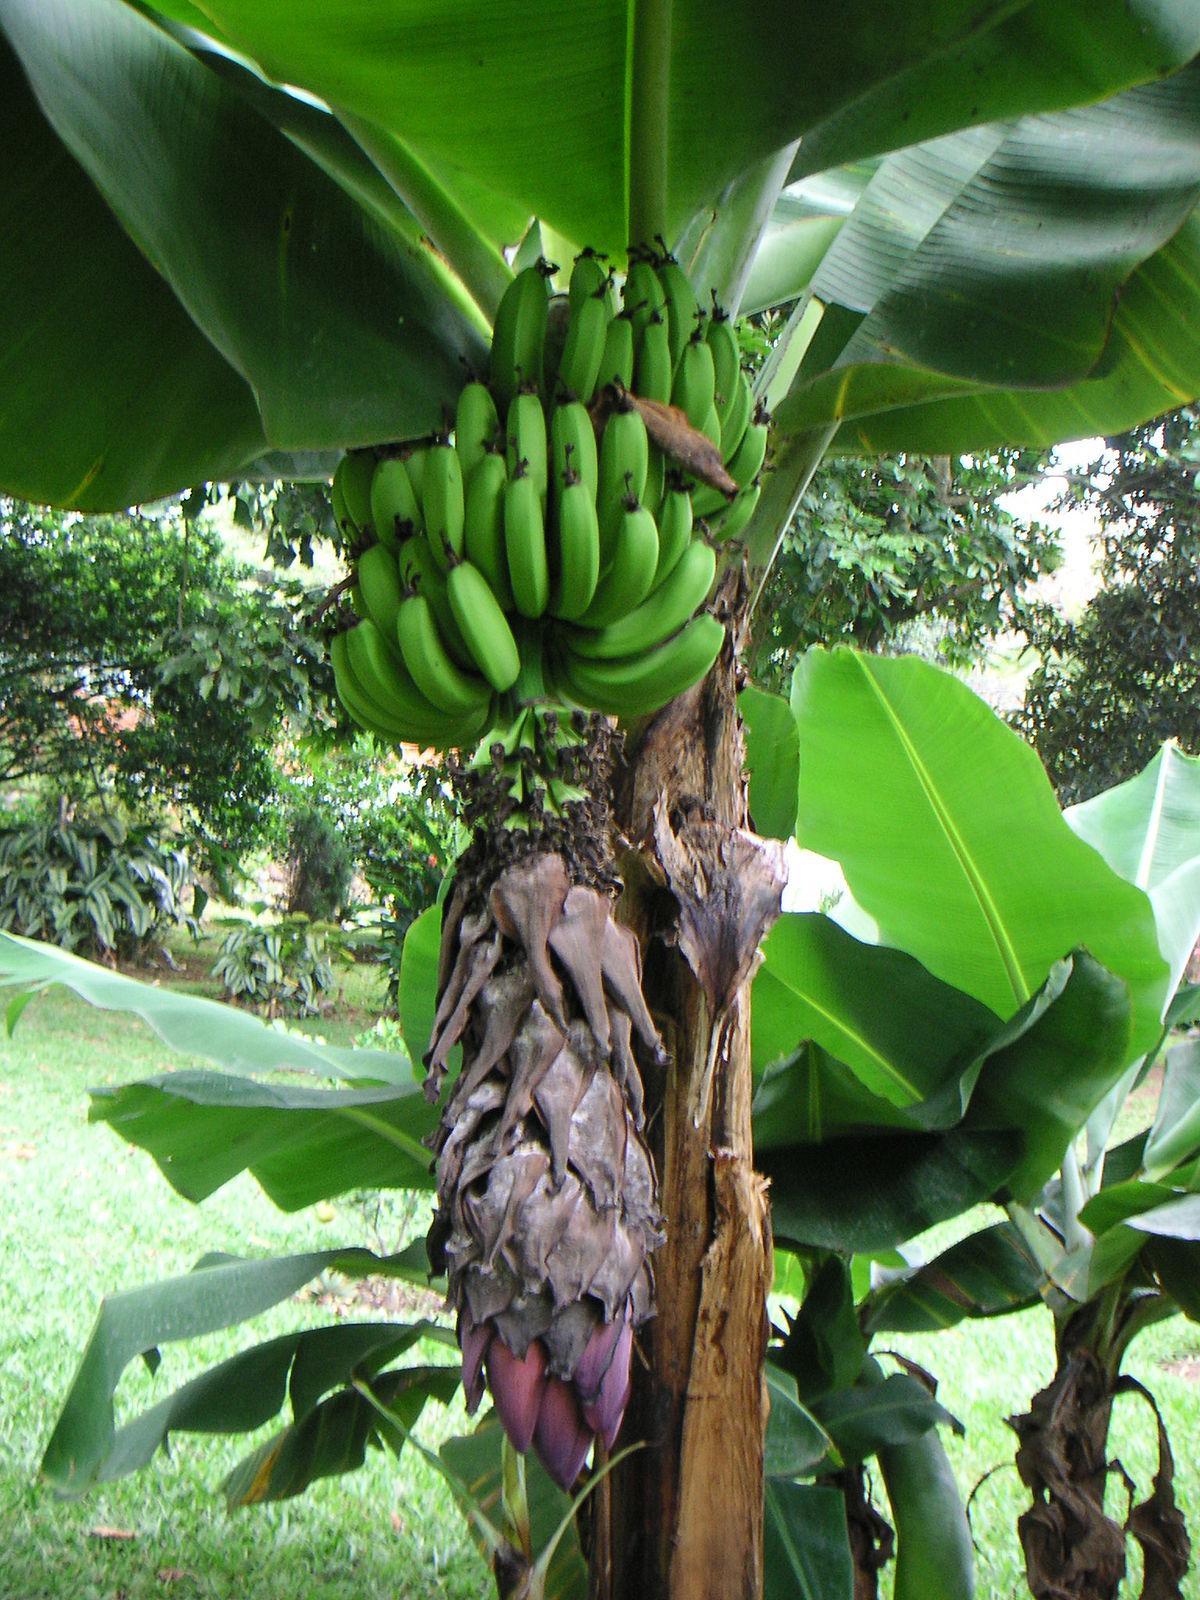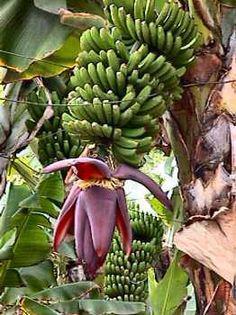The first image is the image on the left, the second image is the image on the right. Evaluate the accuracy of this statement regarding the images: "The righthand image shows a big purple flower with red underside of a petal visible below a bunch of green bananas, but the left image does not show any red undersides of petals.". Is it true? Answer yes or no. Yes. The first image is the image on the left, the second image is the image on the right. Given the left and right images, does the statement "The image to the right is focused on the red flowering bottom of a banana bunch." hold true? Answer yes or no. Yes. 